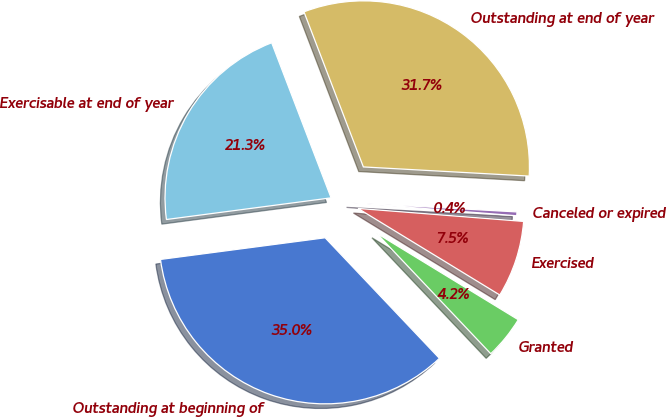<chart> <loc_0><loc_0><loc_500><loc_500><pie_chart><fcel>Outstanding at beginning of<fcel>Granted<fcel>Exercised<fcel>Canceled or expired<fcel>Outstanding at end of year<fcel>Exercisable at end of year<nl><fcel>34.99%<fcel>4.2%<fcel>7.48%<fcel>0.37%<fcel>31.7%<fcel>21.26%<nl></chart> 